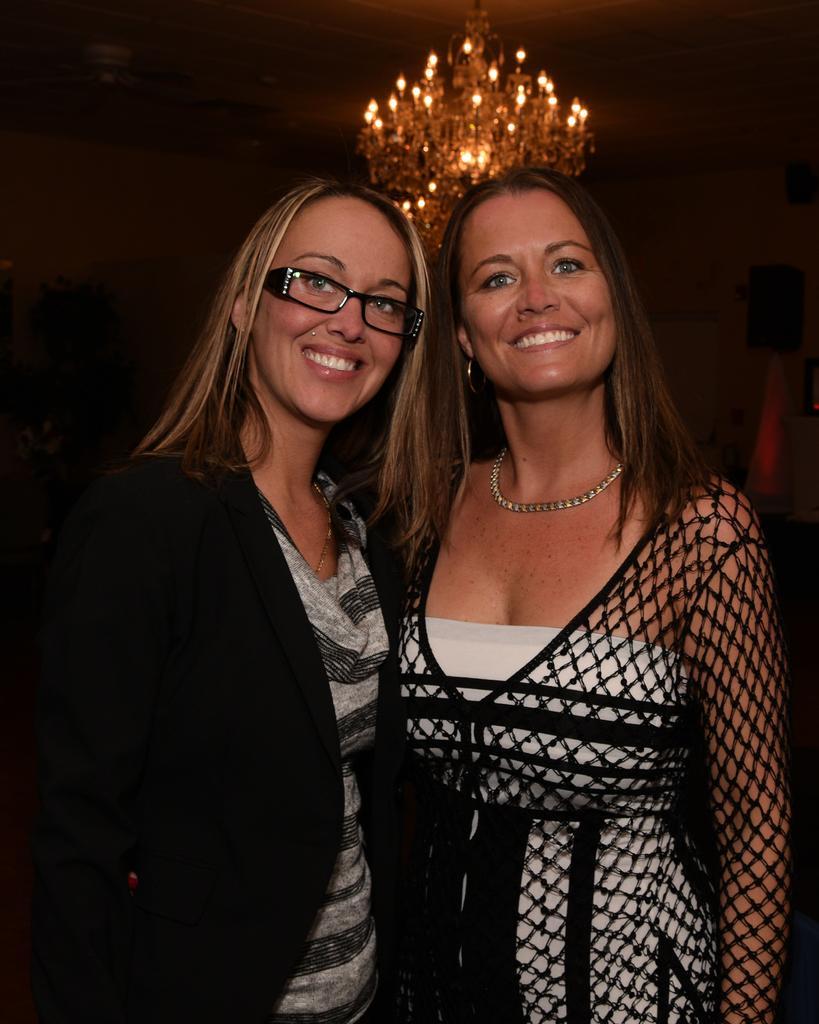Please provide a concise description of this image. This picture seems to be clicked inside the room and we can see the group of persons. In the foreground we can see the two women wearing dresses, smiling and standing. In the background we can see the roof, a chandelier, wall and some other objects. 